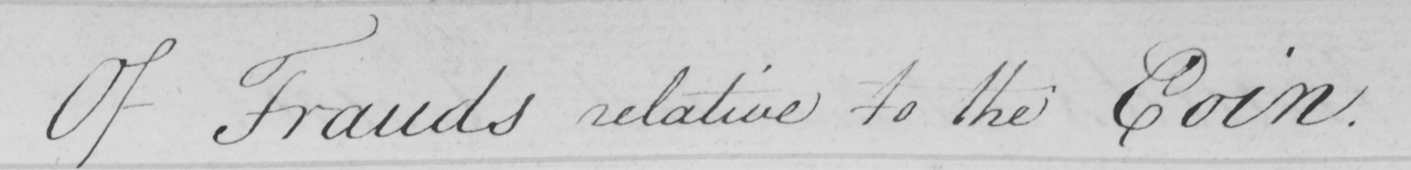Can you read and transcribe this handwriting? Frauds relative to the Coin . 